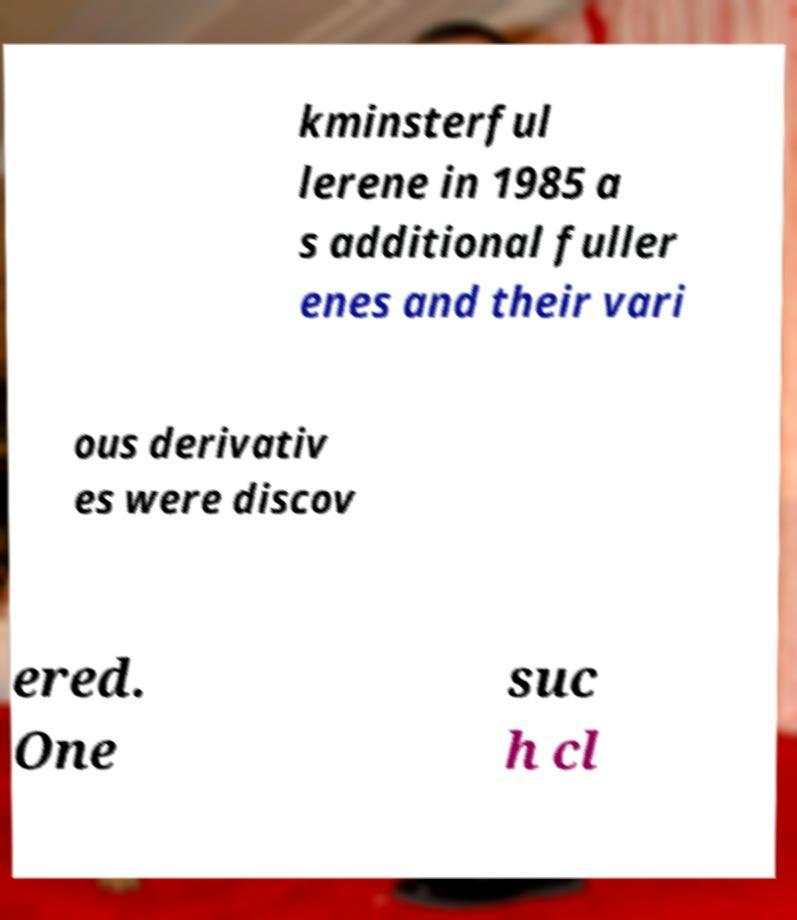Please read and relay the text visible in this image. What does it say? kminsterful lerene in 1985 a s additional fuller enes and their vari ous derivativ es were discov ered. One suc h cl 